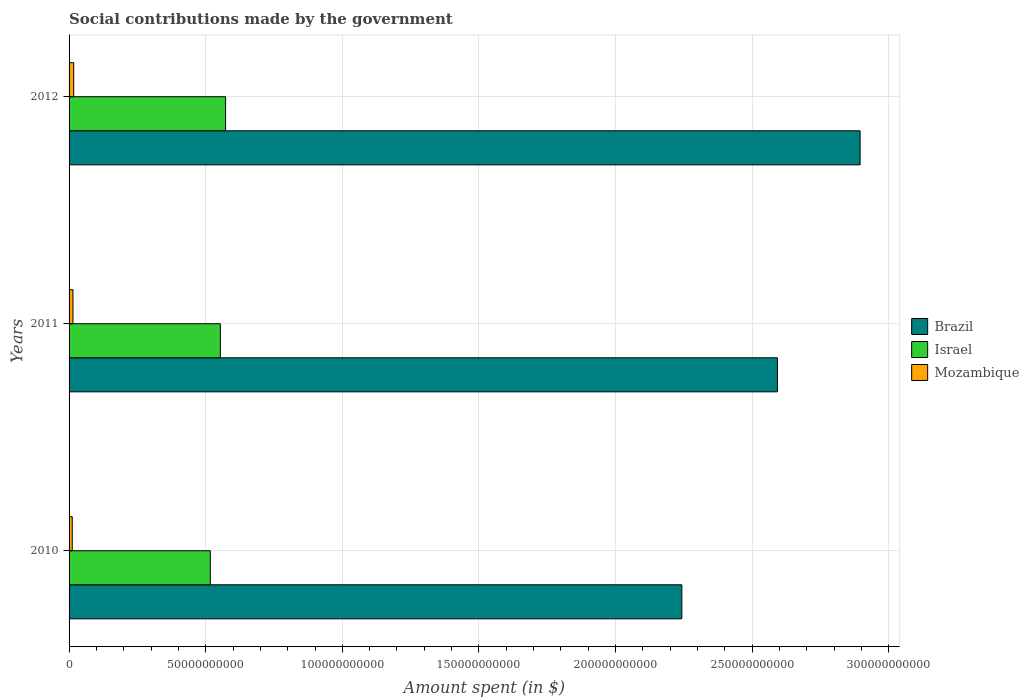How many different coloured bars are there?
Provide a succinct answer. 3. How many groups of bars are there?
Your answer should be compact. 3. How many bars are there on the 1st tick from the top?
Provide a succinct answer. 3. What is the label of the 3rd group of bars from the top?
Give a very brief answer. 2010. In how many cases, is the number of bars for a given year not equal to the number of legend labels?
Ensure brevity in your answer.  0. What is the amount spent on social contributions in Mozambique in 2010?
Keep it short and to the point. 1.16e+09. Across all years, what is the maximum amount spent on social contributions in Brazil?
Your answer should be very brief. 2.89e+11. Across all years, what is the minimum amount spent on social contributions in Brazil?
Offer a very short reply. 2.24e+11. In which year was the amount spent on social contributions in Israel minimum?
Keep it short and to the point. 2010. What is the total amount spent on social contributions in Mozambique in the graph?
Ensure brevity in your answer.  4.27e+09. What is the difference between the amount spent on social contributions in Mozambique in 2010 and that in 2011?
Your answer should be compact. -2.60e+08. What is the difference between the amount spent on social contributions in Mozambique in 2011 and the amount spent on social contributions in Israel in 2012?
Give a very brief answer. -5.59e+1. What is the average amount spent on social contributions in Brazil per year?
Your answer should be compact. 2.58e+11. In the year 2012, what is the difference between the amount spent on social contributions in Israel and amount spent on social contributions in Brazil?
Provide a succinct answer. -2.32e+11. In how many years, is the amount spent on social contributions in Mozambique greater than 230000000000 $?
Ensure brevity in your answer.  0. What is the ratio of the amount spent on social contributions in Mozambique in 2010 to that in 2012?
Provide a short and direct response. 0.69. What is the difference between the highest and the second highest amount spent on social contributions in Israel?
Your response must be concise. 1.92e+09. What is the difference between the highest and the lowest amount spent on social contributions in Brazil?
Make the answer very short. 6.52e+1. In how many years, is the amount spent on social contributions in Brazil greater than the average amount spent on social contributions in Brazil taken over all years?
Offer a very short reply. 2. What does the 1st bar from the top in 2012 represents?
Provide a short and direct response. Mozambique. What does the 1st bar from the bottom in 2012 represents?
Provide a succinct answer. Brazil. How many years are there in the graph?
Offer a very short reply. 3. Are the values on the major ticks of X-axis written in scientific E-notation?
Make the answer very short. No. Does the graph contain any zero values?
Provide a succinct answer. No. Does the graph contain grids?
Offer a terse response. Yes. Where does the legend appear in the graph?
Give a very brief answer. Center right. How are the legend labels stacked?
Make the answer very short. Vertical. What is the title of the graph?
Your response must be concise. Social contributions made by the government. What is the label or title of the X-axis?
Keep it short and to the point. Amount spent (in $). What is the label or title of the Y-axis?
Give a very brief answer. Years. What is the Amount spent (in $) in Brazil in 2010?
Provide a succinct answer. 2.24e+11. What is the Amount spent (in $) in Israel in 2010?
Ensure brevity in your answer.  5.17e+1. What is the Amount spent (in $) in Mozambique in 2010?
Keep it short and to the point. 1.16e+09. What is the Amount spent (in $) of Brazil in 2011?
Offer a very short reply. 2.59e+11. What is the Amount spent (in $) of Israel in 2011?
Ensure brevity in your answer.  5.54e+1. What is the Amount spent (in $) of Mozambique in 2011?
Provide a succinct answer. 1.42e+09. What is the Amount spent (in $) in Brazil in 2012?
Ensure brevity in your answer.  2.89e+11. What is the Amount spent (in $) in Israel in 2012?
Provide a short and direct response. 5.73e+1. What is the Amount spent (in $) of Mozambique in 2012?
Make the answer very short. 1.69e+09. Across all years, what is the maximum Amount spent (in $) of Brazil?
Ensure brevity in your answer.  2.89e+11. Across all years, what is the maximum Amount spent (in $) of Israel?
Make the answer very short. 5.73e+1. Across all years, what is the maximum Amount spent (in $) of Mozambique?
Provide a short and direct response. 1.69e+09. Across all years, what is the minimum Amount spent (in $) of Brazil?
Offer a terse response. 2.24e+11. Across all years, what is the minimum Amount spent (in $) of Israel?
Offer a very short reply. 5.17e+1. Across all years, what is the minimum Amount spent (in $) in Mozambique?
Offer a very short reply. 1.16e+09. What is the total Amount spent (in $) in Brazil in the graph?
Make the answer very short. 7.73e+11. What is the total Amount spent (in $) of Israel in the graph?
Provide a succinct answer. 1.64e+11. What is the total Amount spent (in $) of Mozambique in the graph?
Make the answer very short. 4.27e+09. What is the difference between the Amount spent (in $) of Brazil in 2010 and that in 2011?
Your answer should be compact. -3.50e+1. What is the difference between the Amount spent (in $) of Israel in 2010 and that in 2011?
Offer a terse response. -3.69e+09. What is the difference between the Amount spent (in $) in Mozambique in 2010 and that in 2011?
Give a very brief answer. -2.60e+08. What is the difference between the Amount spent (in $) in Brazil in 2010 and that in 2012?
Keep it short and to the point. -6.52e+1. What is the difference between the Amount spent (in $) in Israel in 2010 and that in 2012?
Ensure brevity in your answer.  -5.61e+09. What is the difference between the Amount spent (in $) of Mozambique in 2010 and that in 2012?
Your answer should be compact. -5.26e+08. What is the difference between the Amount spent (in $) of Brazil in 2011 and that in 2012?
Your answer should be compact. -3.02e+1. What is the difference between the Amount spent (in $) in Israel in 2011 and that in 2012?
Keep it short and to the point. -1.92e+09. What is the difference between the Amount spent (in $) in Mozambique in 2011 and that in 2012?
Provide a succinct answer. -2.67e+08. What is the difference between the Amount spent (in $) of Brazil in 2010 and the Amount spent (in $) of Israel in 2011?
Keep it short and to the point. 1.69e+11. What is the difference between the Amount spent (in $) in Brazil in 2010 and the Amount spent (in $) in Mozambique in 2011?
Your answer should be compact. 2.23e+11. What is the difference between the Amount spent (in $) of Israel in 2010 and the Amount spent (in $) of Mozambique in 2011?
Ensure brevity in your answer.  5.03e+1. What is the difference between the Amount spent (in $) of Brazil in 2010 and the Amount spent (in $) of Israel in 2012?
Ensure brevity in your answer.  1.67e+11. What is the difference between the Amount spent (in $) of Brazil in 2010 and the Amount spent (in $) of Mozambique in 2012?
Ensure brevity in your answer.  2.23e+11. What is the difference between the Amount spent (in $) of Israel in 2010 and the Amount spent (in $) of Mozambique in 2012?
Offer a terse response. 5.00e+1. What is the difference between the Amount spent (in $) of Brazil in 2011 and the Amount spent (in $) of Israel in 2012?
Your response must be concise. 2.02e+11. What is the difference between the Amount spent (in $) in Brazil in 2011 and the Amount spent (in $) in Mozambique in 2012?
Provide a short and direct response. 2.58e+11. What is the difference between the Amount spent (in $) in Israel in 2011 and the Amount spent (in $) in Mozambique in 2012?
Your answer should be compact. 5.37e+1. What is the average Amount spent (in $) of Brazil per year?
Provide a succinct answer. 2.58e+11. What is the average Amount spent (in $) of Israel per year?
Provide a short and direct response. 5.48e+1. What is the average Amount spent (in $) of Mozambique per year?
Your response must be concise. 1.42e+09. In the year 2010, what is the difference between the Amount spent (in $) of Brazil and Amount spent (in $) of Israel?
Give a very brief answer. 1.73e+11. In the year 2010, what is the difference between the Amount spent (in $) in Brazil and Amount spent (in $) in Mozambique?
Offer a very short reply. 2.23e+11. In the year 2010, what is the difference between the Amount spent (in $) of Israel and Amount spent (in $) of Mozambique?
Keep it short and to the point. 5.05e+1. In the year 2011, what is the difference between the Amount spent (in $) of Brazil and Amount spent (in $) of Israel?
Keep it short and to the point. 2.04e+11. In the year 2011, what is the difference between the Amount spent (in $) of Brazil and Amount spent (in $) of Mozambique?
Give a very brief answer. 2.58e+11. In the year 2011, what is the difference between the Amount spent (in $) of Israel and Amount spent (in $) of Mozambique?
Your response must be concise. 5.39e+1. In the year 2012, what is the difference between the Amount spent (in $) in Brazil and Amount spent (in $) in Israel?
Offer a terse response. 2.32e+11. In the year 2012, what is the difference between the Amount spent (in $) of Brazil and Amount spent (in $) of Mozambique?
Offer a very short reply. 2.88e+11. In the year 2012, what is the difference between the Amount spent (in $) of Israel and Amount spent (in $) of Mozambique?
Your answer should be very brief. 5.56e+1. What is the ratio of the Amount spent (in $) of Brazil in 2010 to that in 2011?
Provide a short and direct response. 0.86. What is the ratio of the Amount spent (in $) in Israel in 2010 to that in 2011?
Keep it short and to the point. 0.93. What is the ratio of the Amount spent (in $) of Mozambique in 2010 to that in 2011?
Offer a terse response. 0.82. What is the ratio of the Amount spent (in $) in Brazil in 2010 to that in 2012?
Your answer should be compact. 0.77. What is the ratio of the Amount spent (in $) in Israel in 2010 to that in 2012?
Your answer should be compact. 0.9. What is the ratio of the Amount spent (in $) of Mozambique in 2010 to that in 2012?
Your answer should be very brief. 0.69. What is the ratio of the Amount spent (in $) in Brazil in 2011 to that in 2012?
Give a very brief answer. 0.9. What is the ratio of the Amount spent (in $) of Israel in 2011 to that in 2012?
Keep it short and to the point. 0.97. What is the ratio of the Amount spent (in $) of Mozambique in 2011 to that in 2012?
Offer a terse response. 0.84. What is the difference between the highest and the second highest Amount spent (in $) of Brazil?
Offer a very short reply. 3.02e+1. What is the difference between the highest and the second highest Amount spent (in $) of Israel?
Keep it short and to the point. 1.92e+09. What is the difference between the highest and the second highest Amount spent (in $) in Mozambique?
Offer a very short reply. 2.67e+08. What is the difference between the highest and the lowest Amount spent (in $) of Brazil?
Provide a succinct answer. 6.52e+1. What is the difference between the highest and the lowest Amount spent (in $) of Israel?
Provide a short and direct response. 5.61e+09. What is the difference between the highest and the lowest Amount spent (in $) of Mozambique?
Ensure brevity in your answer.  5.26e+08. 